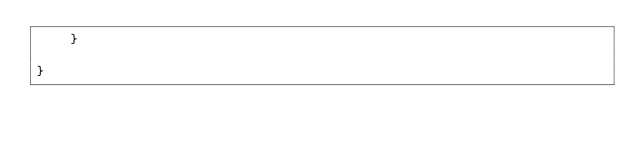Convert code to text. <code><loc_0><loc_0><loc_500><loc_500><_Java_>	}

}
</code> 